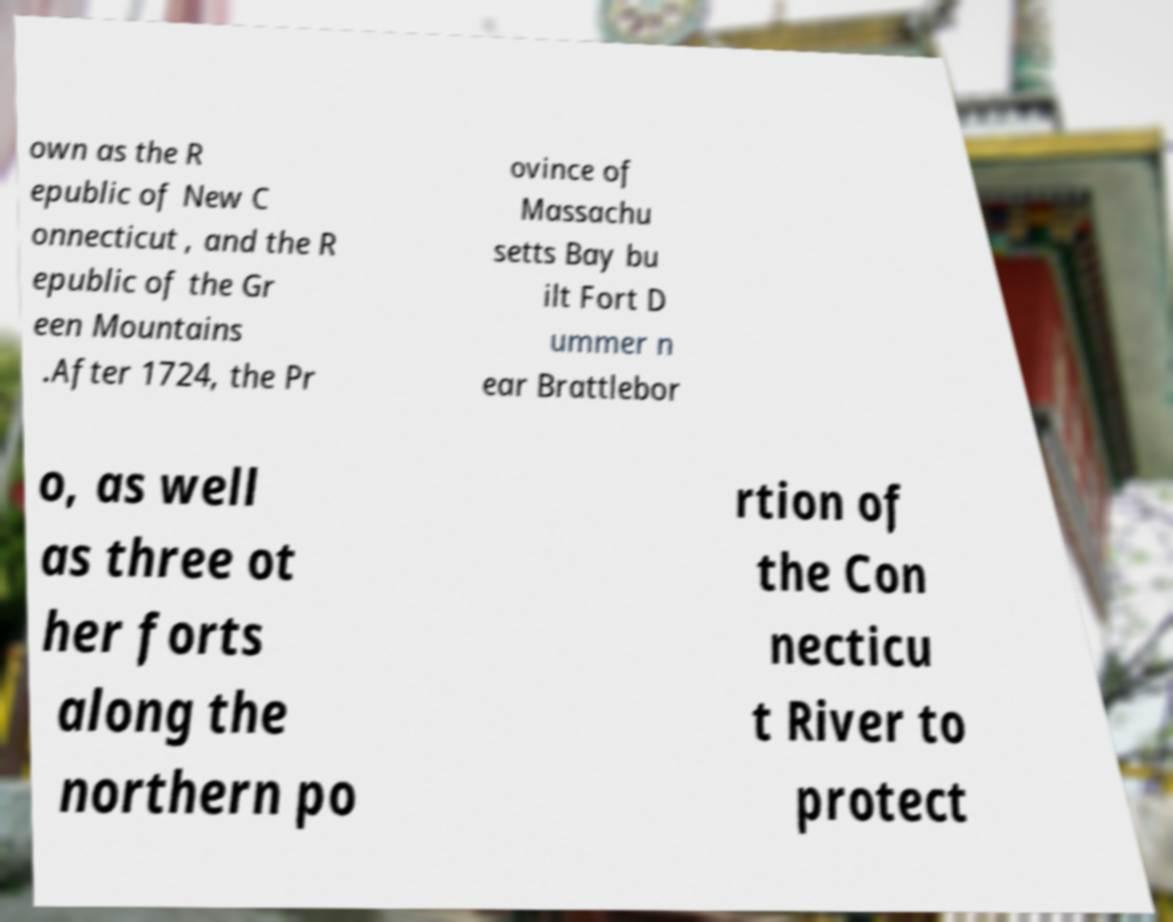What messages or text are displayed in this image? I need them in a readable, typed format. own as the R epublic of New C onnecticut , and the R epublic of the Gr een Mountains .After 1724, the Pr ovince of Massachu setts Bay bu ilt Fort D ummer n ear Brattlebor o, as well as three ot her forts along the northern po rtion of the Con necticu t River to protect 